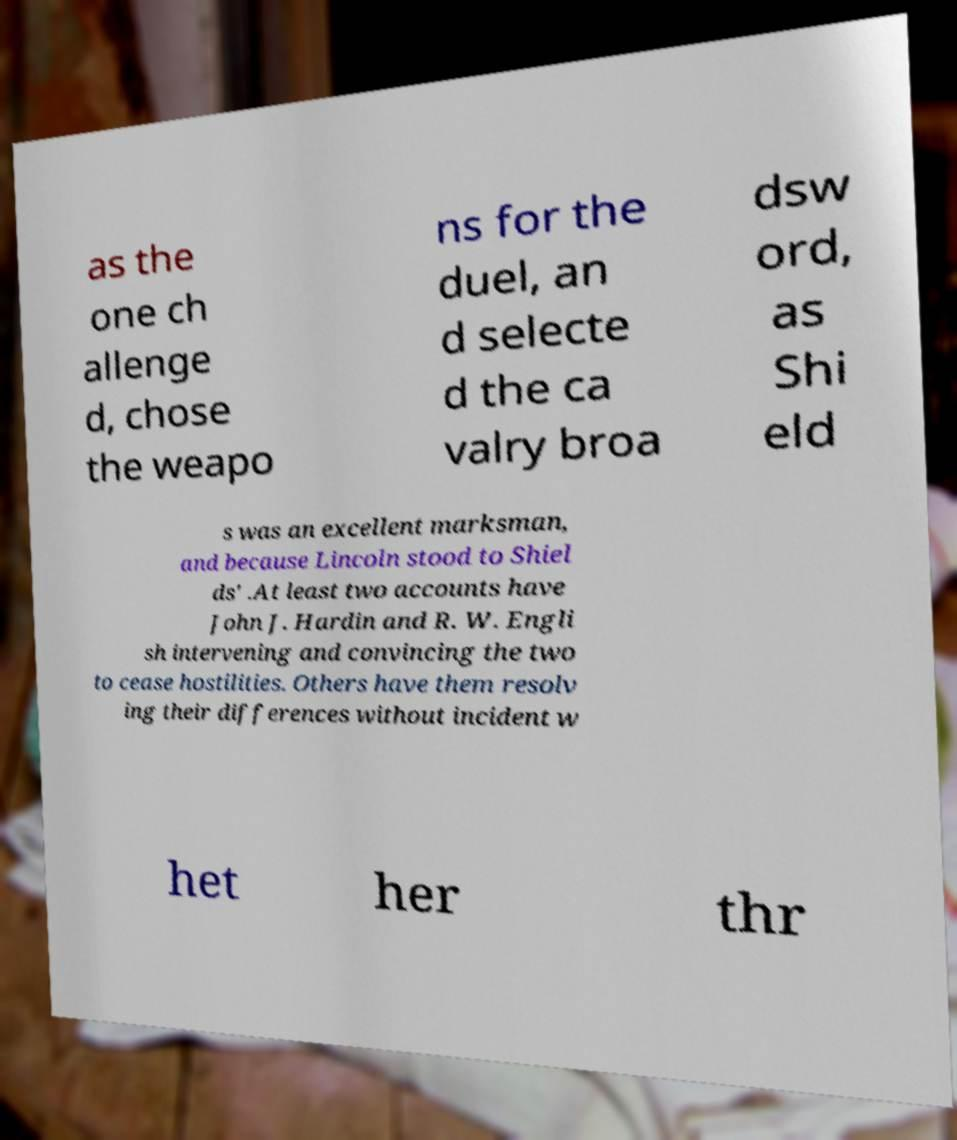What messages or text are displayed in this image? I need them in a readable, typed format. as the one ch allenge d, chose the weapo ns for the duel, an d selecte d the ca valry broa dsw ord, as Shi eld s was an excellent marksman, and because Lincoln stood to Shiel ds' .At least two accounts have John J. Hardin and R. W. Engli sh intervening and convincing the two to cease hostilities. Others have them resolv ing their differences without incident w het her thr 